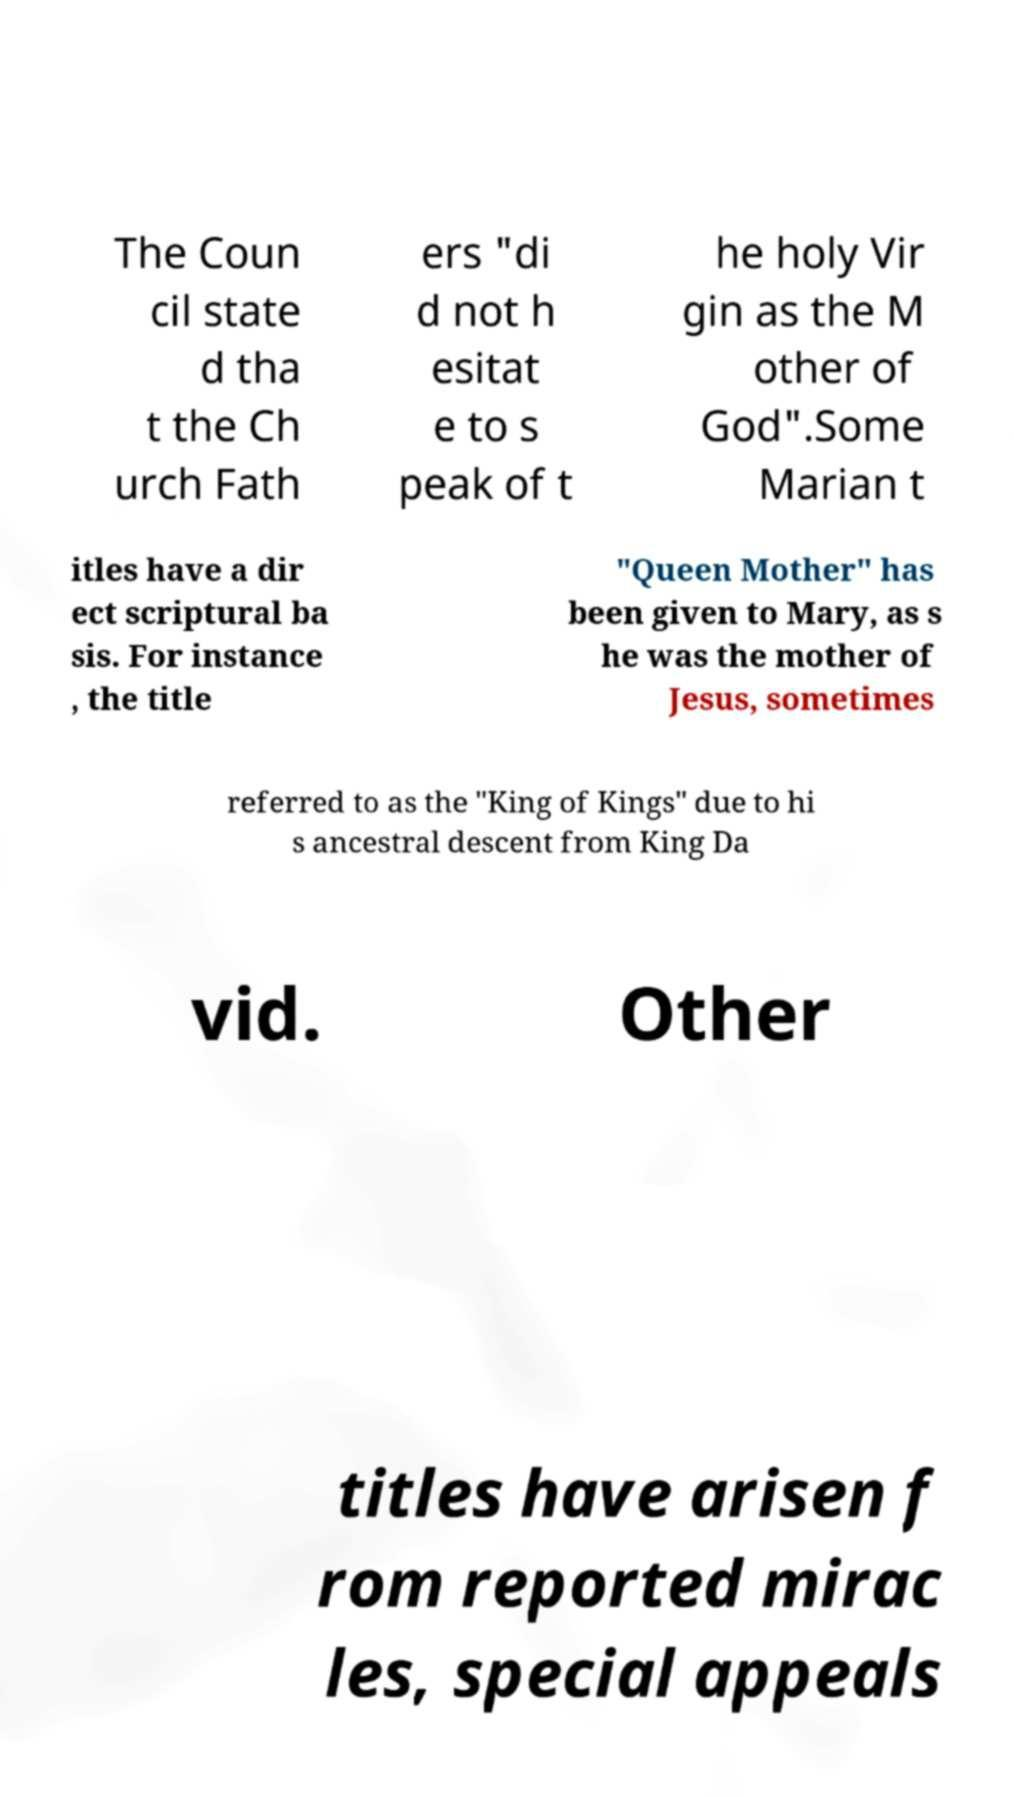Please read and relay the text visible in this image. What does it say? The Coun cil state d tha t the Ch urch Fath ers "di d not h esitat e to s peak of t he holy Vir gin as the M other of God".Some Marian t itles have a dir ect scriptural ba sis. For instance , the title "Queen Mother" has been given to Mary, as s he was the mother of Jesus, sometimes referred to as the "King of Kings" due to hi s ancestral descent from King Da vid. Other titles have arisen f rom reported mirac les, special appeals 